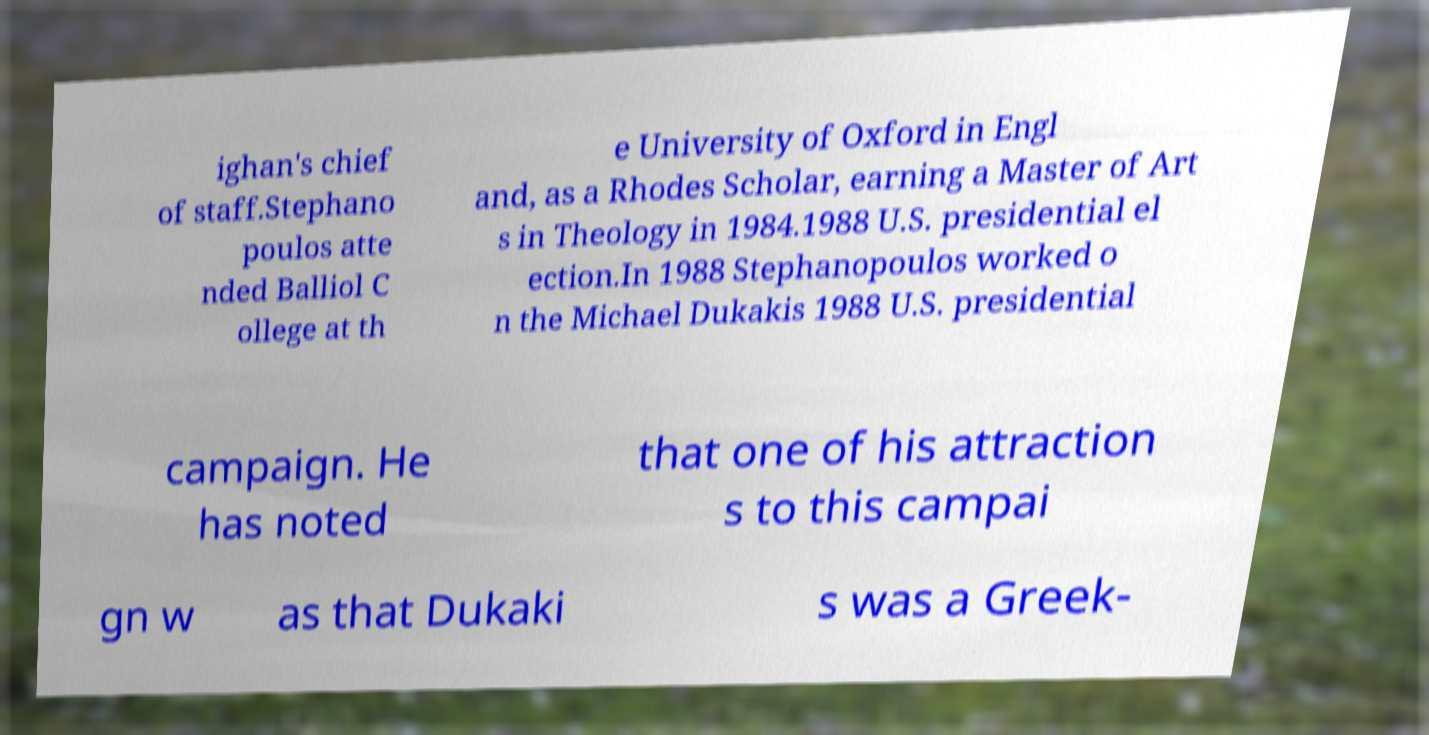What messages or text are displayed in this image? I need them in a readable, typed format. ighan's chief of staff.Stephano poulos atte nded Balliol C ollege at th e University of Oxford in Engl and, as a Rhodes Scholar, earning a Master of Art s in Theology in 1984.1988 U.S. presidential el ection.In 1988 Stephanopoulos worked o n the Michael Dukakis 1988 U.S. presidential campaign. He has noted that one of his attraction s to this campai gn w as that Dukaki s was a Greek- 